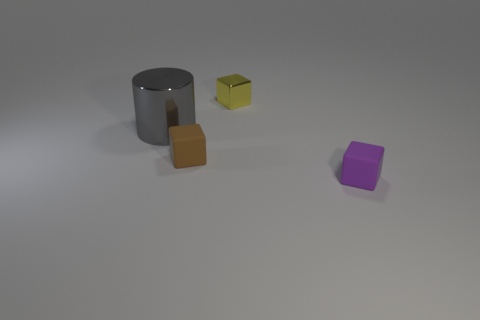Add 4 yellow objects. How many objects exist? 8 Subtract all blocks. How many objects are left? 1 Add 4 tiny yellow things. How many tiny yellow things are left? 5 Add 2 tiny metal things. How many tiny metal things exist? 3 Subtract 0 cyan spheres. How many objects are left? 4 Subtract all purple rubber cubes. Subtract all small purple cubes. How many objects are left? 2 